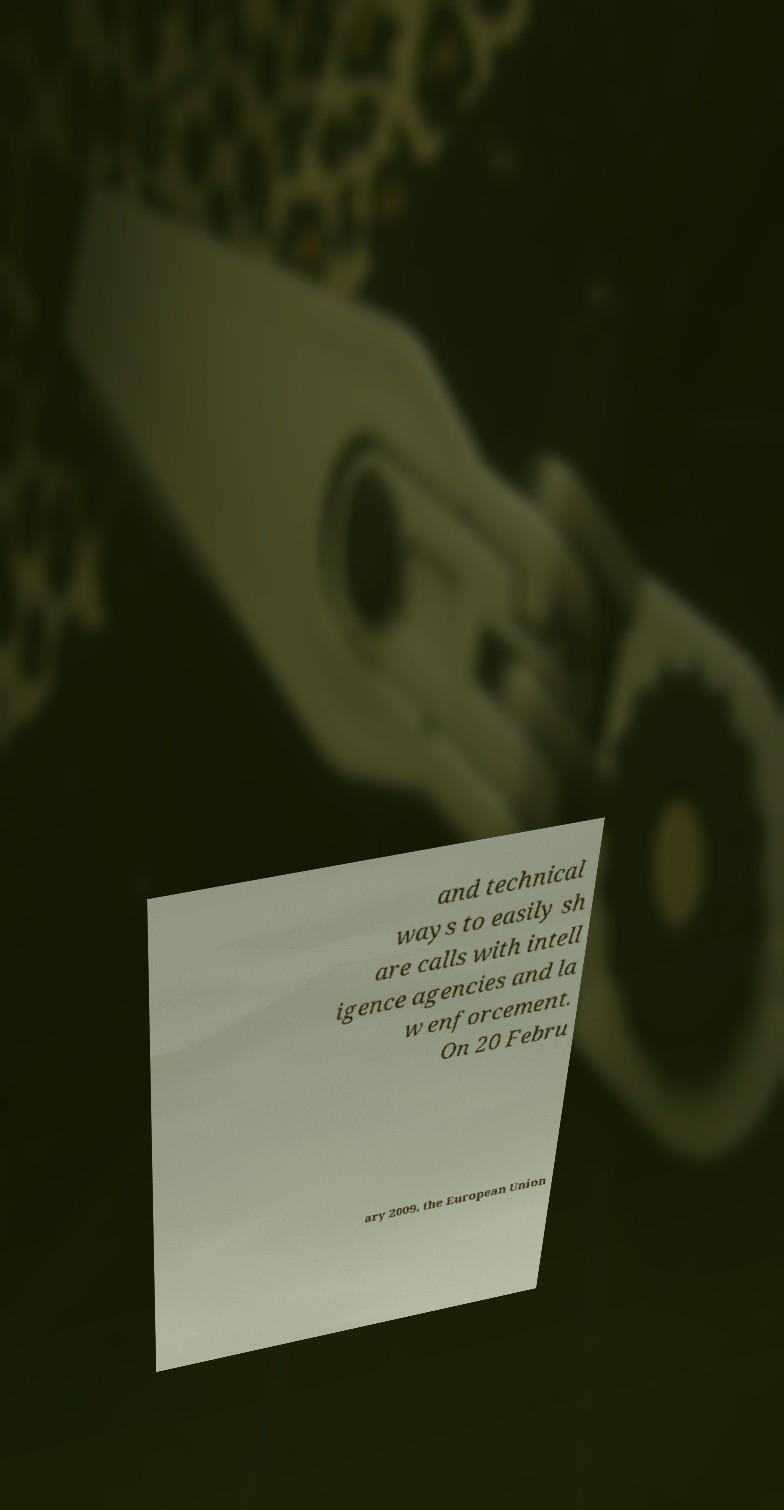Can you accurately transcribe the text from the provided image for me? and technical ways to easily sh are calls with intell igence agencies and la w enforcement. On 20 Febru ary 2009, the European Union 